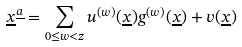<formula> <loc_0><loc_0><loc_500><loc_500>\underline { x } ^ { \underline { a } } = \sum _ { 0 \leq w < z } u ^ { ( w ) } ( \underline { x } ) g ^ { ( w ) } ( \underline { x } ) + v ( \underline { x } )</formula> 